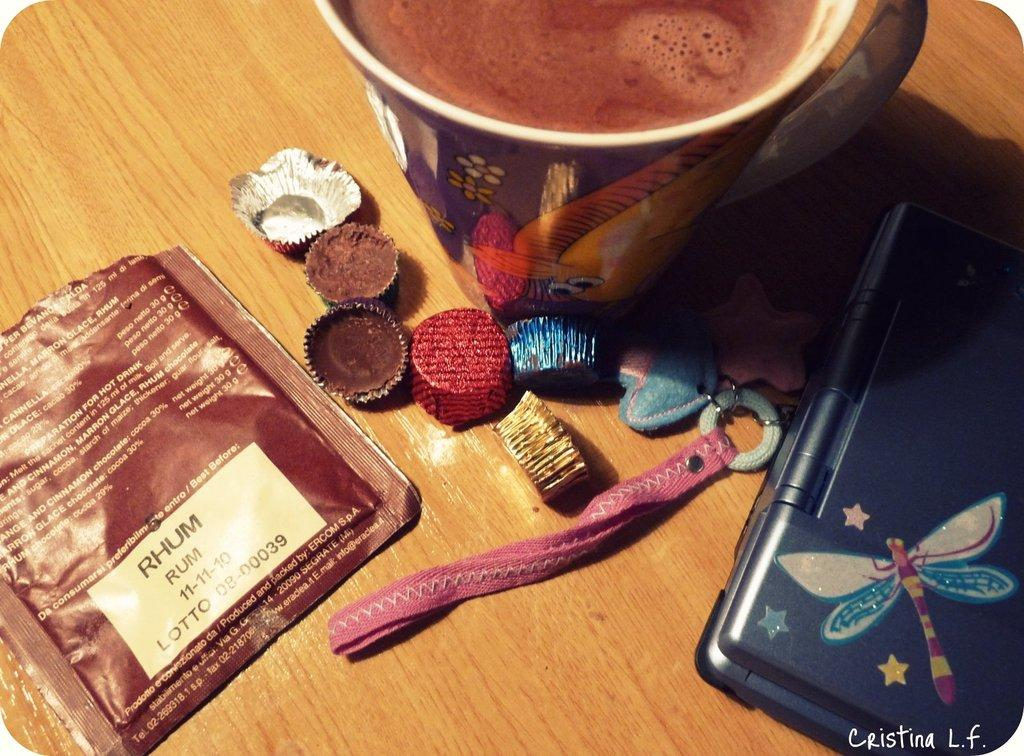What type of food is contained in the packet in the image? The facts do not specify the type of food in the packet. What type of sweets are visible in the image? There are chocolates in the image. What is in the mug in the image? There is a drink in the mug in the image. What is the wooden platform supporting in the image? The facts do not specify what the object on the wooden platform is. What can be seen as a watermark in the image? There is a watermark in the image. What song is being played in the background of the image? There is no information about any song being played in the image. Is there a pear visible in the image? There is no mention of a pear in the image. 